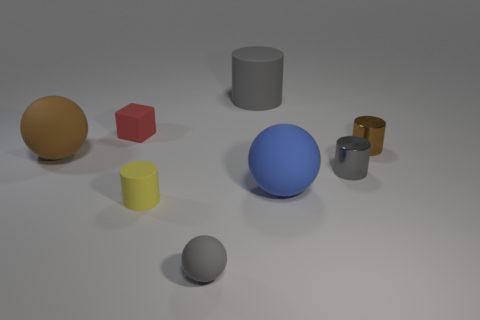What is the largest object in this image? The largest object appears to be the blue sphere located near the center of the image. Is there any object that looks particularly reflective? Yes, the silver sphere towards the bottom-right exhibits a noticeable reflection on its surface. 